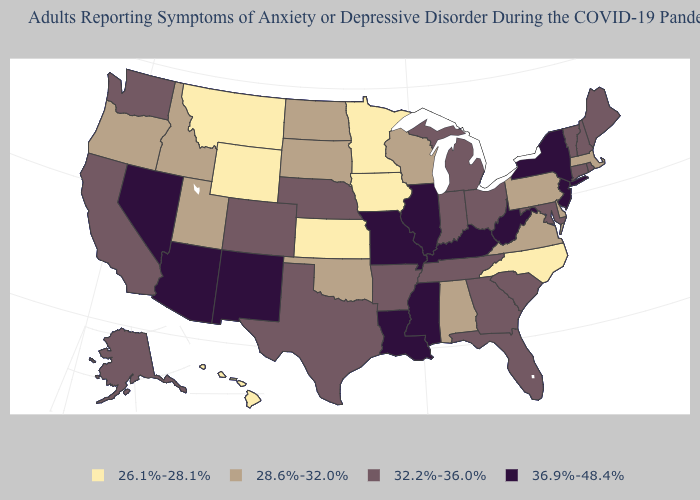Among the states that border Massachusetts , does Vermont have the lowest value?
Be succinct. Yes. Does Alaska have the same value as Colorado?
Quick response, please. Yes. How many symbols are there in the legend?
Give a very brief answer. 4. Among the states that border Tennessee , does Kentucky have the highest value?
Keep it brief. Yes. Name the states that have a value in the range 32.2%-36.0%?
Give a very brief answer. Alaska, Arkansas, California, Colorado, Connecticut, Florida, Georgia, Indiana, Maine, Maryland, Michigan, Nebraska, New Hampshire, Ohio, Rhode Island, South Carolina, Tennessee, Texas, Vermont, Washington. Which states hav the highest value in the West?
Be succinct. Arizona, Nevada, New Mexico. What is the lowest value in the Northeast?
Be succinct. 28.6%-32.0%. What is the value of Indiana?
Give a very brief answer. 32.2%-36.0%. Which states have the highest value in the USA?
Write a very short answer. Arizona, Illinois, Kentucky, Louisiana, Mississippi, Missouri, Nevada, New Jersey, New Mexico, New York, West Virginia. What is the value of Kentucky?
Write a very short answer. 36.9%-48.4%. What is the value of New York?
Give a very brief answer. 36.9%-48.4%. What is the value of Minnesota?
Concise answer only. 26.1%-28.1%. Name the states that have a value in the range 36.9%-48.4%?
Write a very short answer. Arizona, Illinois, Kentucky, Louisiana, Mississippi, Missouri, Nevada, New Jersey, New Mexico, New York, West Virginia. What is the lowest value in the USA?
Quick response, please. 26.1%-28.1%. What is the value of Delaware?
Quick response, please. 28.6%-32.0%. 